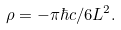<formula> <loc_0><loc_0><loc_500><loc_500>\rho = - \pi \hbar { c } / 6 L ^ { 2 } .</formula> 